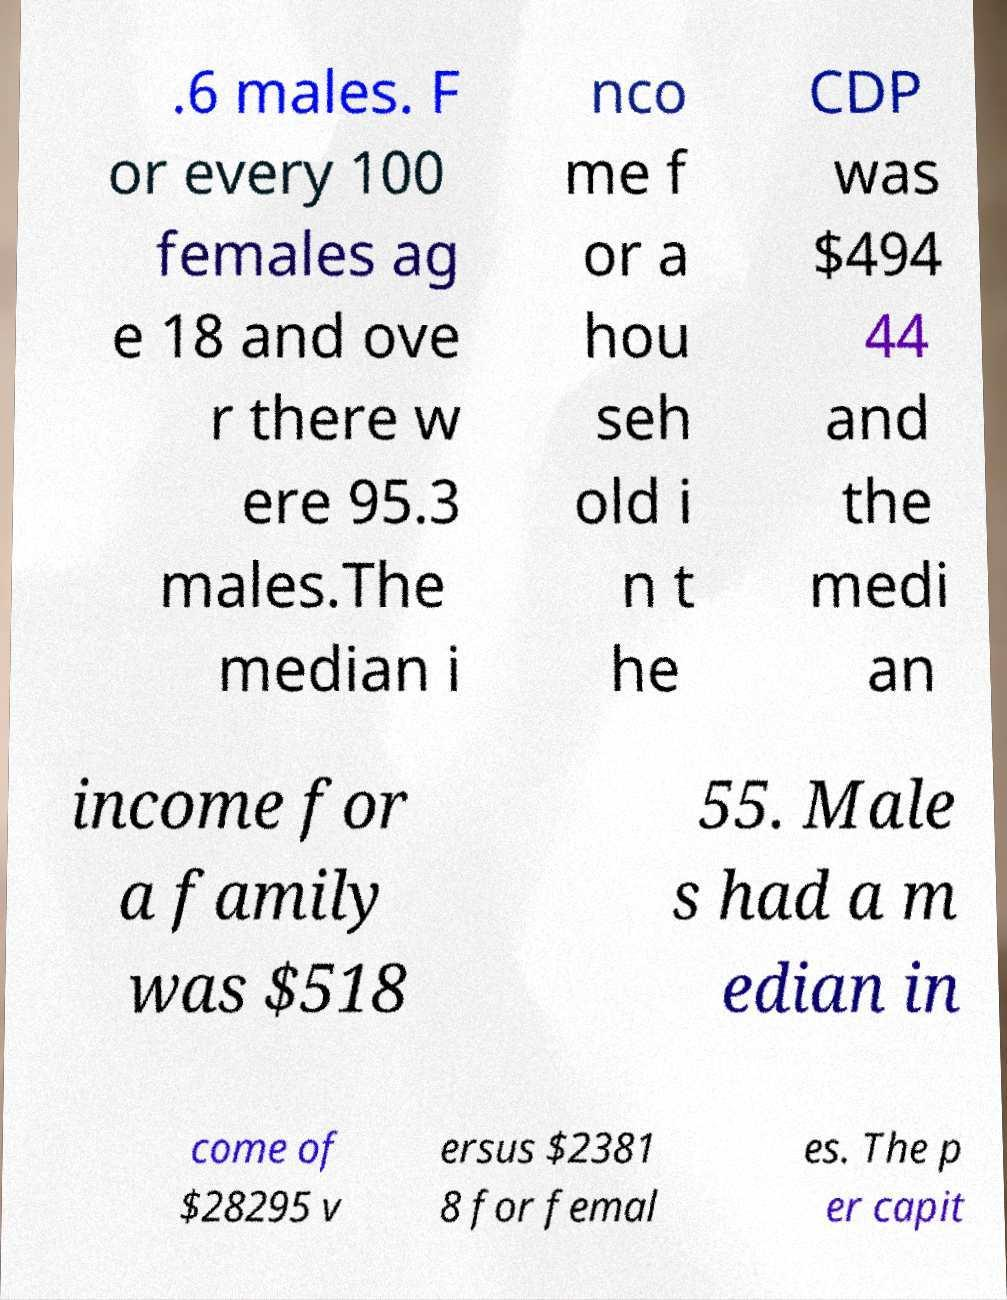Please identify and transcribe the text found in this image. .6 males. F or every 100 females ag e 18 and ove r there w ere 95.3 males.The median i nco me f or a hou seh old i n t he CDP was $494 44 and the medi an income for a family was $518 55. Male s had a m edian in come of $28295 v ersus $2381 8 for femal es. The p er capit 